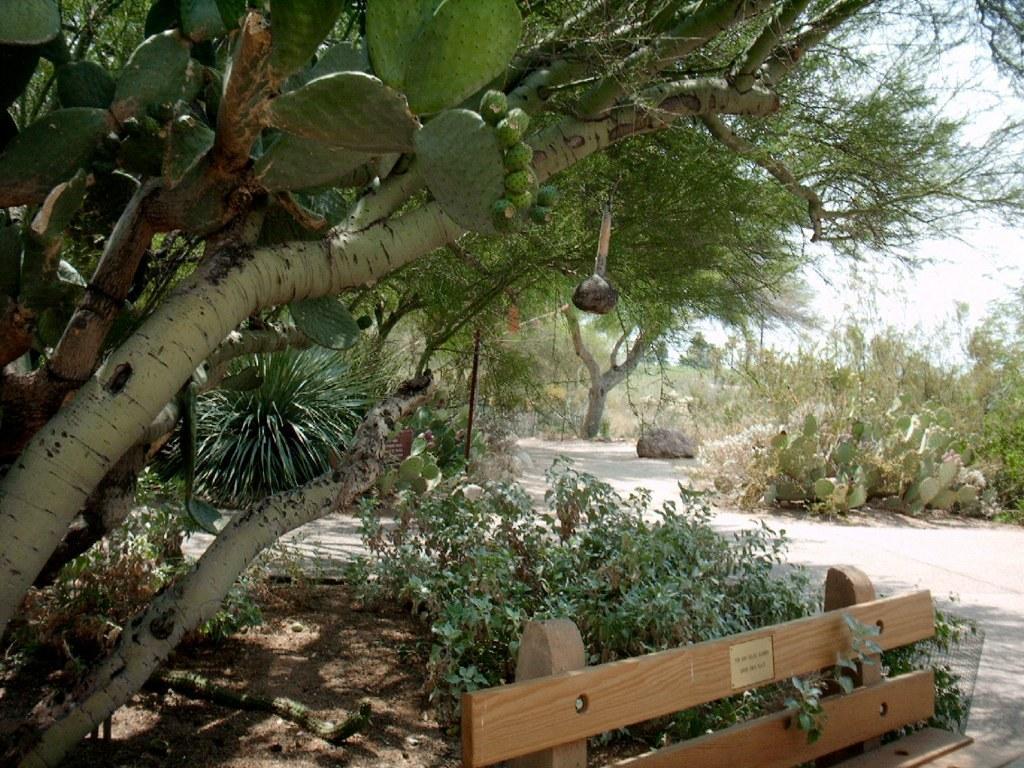Please provide a concise description of this image. At the bottom of the image we can see a bench and plants. In the background there are trees and sky. 